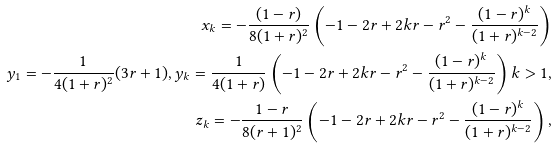Convert formula to latex. <formula><loc_0><loc_0><loc_500><loc_500>x _ { k } = - \frac { ( 1 - r ) } { 8 ( 1 + r ) ^ { 2 } } \left ( - 1 - 2 r + 2 k r - r ^ { 2 } - \frac { ( 1 - r ) ^ { k } } { ( 1 + r ) ^ { k - 2 } } \right ) \\ y _ { 1 } = - \frac { 1 } { 4 ( 1 + r ) ^ { 2 } } ( 3 r + 1 ) , y _ { k } = \frac { 1 } { 4 ( 1 + r ) } \left ( - 1 - 2 r + 2 k r - r ^ { 2 } - \frac { ( 1 - r ) ^ { k } } { ( 1 + r ) ^ { k - 2 } } \right ) k > 1 , \\ z _ { k } = - \frac { 1 - r } { 8 ( r + 1 ) ^ { 2 } } \left ( - 1 - 2 r + 2 k r - r ^ { 2 } - \frac { ( 1 - r ) ^ { k } } { ( 1 + r ) ^ { k - 2 } } \right ) , \\</formula> 